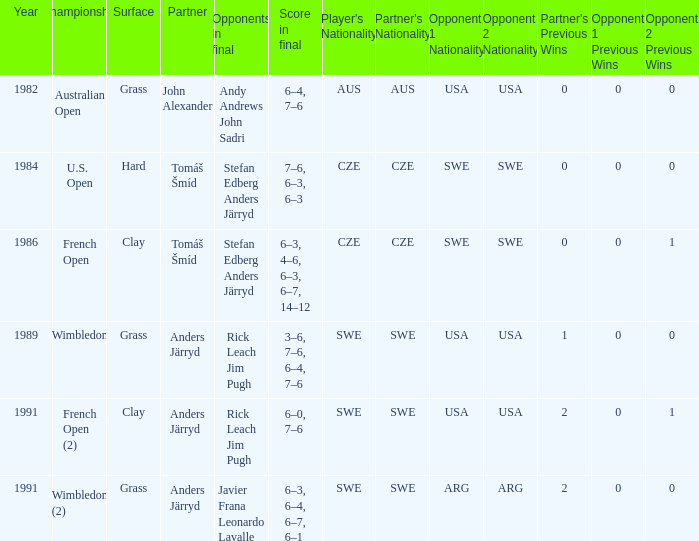What was the surface when he played with John Alexander?  Grass. I'm looking to parse the entire table for insights. Could you assist me with that? {'header': ['Year', 'Championship', 'Surface', 'Partner', 'Opponents in final', 'Score in final', "Player's Nationality", "Partner's Nationality", 'Opponent 1 Nationality', 'Opponent 2 Nationality', "Partner's Previous Wins", 'Opponent 1 Previous Wins', 'Opponent 2 Previous Wins'], 'rows': [['1982', 'Australian Open', 'Grass', 'John Alexander', 'Andy Andrews John Sadri', '6–4, 7–6', 'AUS', 'AUS', 'USA', 'USA', '0', '0', '0'], ['1984', 'U.S. Open', 'Hard', 'Tomáš Šmíd', 'Stefan Edberg Anders Järryd', '7–6, 6–3, 6–3', 'CZE', 'CZE', 'SWE', 'SWE', '0', '0', '0'], ['1986', 'French Open', 'Clay', 'Tomáš Šmíd', 'Stefan Edberg Anders Järryd', '6–3, 4–6, 6–3, 6–7, 14–12', 'CZE', 'CZE', 'SWE', 'SWE', '0', '0', '1'], ['1989', 'Wimbledon', 'Grass', 'Anders Järryd', 'Rick Leach Jim Pugh', '3–6, 7–6, 6–4, 7–6', 'SWE', 'SWE', 'USA', 'USA', '1', '0', '0'], ['1991', 'French Open (2)', 'Clay', 'Anders Järryd', 'Rick Leach Jim Pugh', '6–0, 7–6', 'SWE', 'SWE', 'USA', 'USA', '2', '0', '1'], ['1991', 'Wimbledon (2)', 'Grass', 'Anders Järryd', 'Javier Frana Leonardo Lavalle', '6–3, 6–4, 6–7, 6–1', 'SWE', 'SWE', 'ARG', 'ARG', '2', '0', '0']]} 